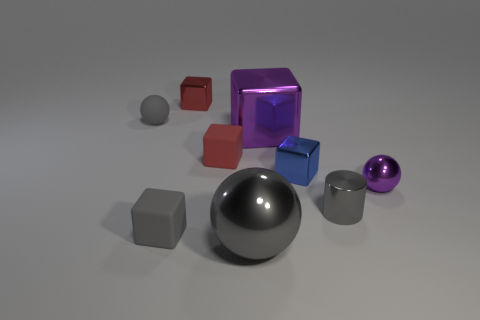Subtract all small blocks. How many blocks are left? 1 Subtract all brown balls. How many red blocks are left? 2 Subtract 1 balls. How many balls are left? 2 Subtract all cubes. How many objects are left? 4 Subtract all red cubes. How many cubes are left? 3 Subtract 0 cyan cylinders. How many objects are left? 9 Subtract all red blocks. Subtract all purple balls. How many blocks are left? 3 Subtract all red rubber objects. Subtract all gray matte objects. How many objects are left? 6 Add 5 large metal blocks. How many large metal blocks are left? 6 Add 1 red shiny things. How many red shiny things exist? 2 